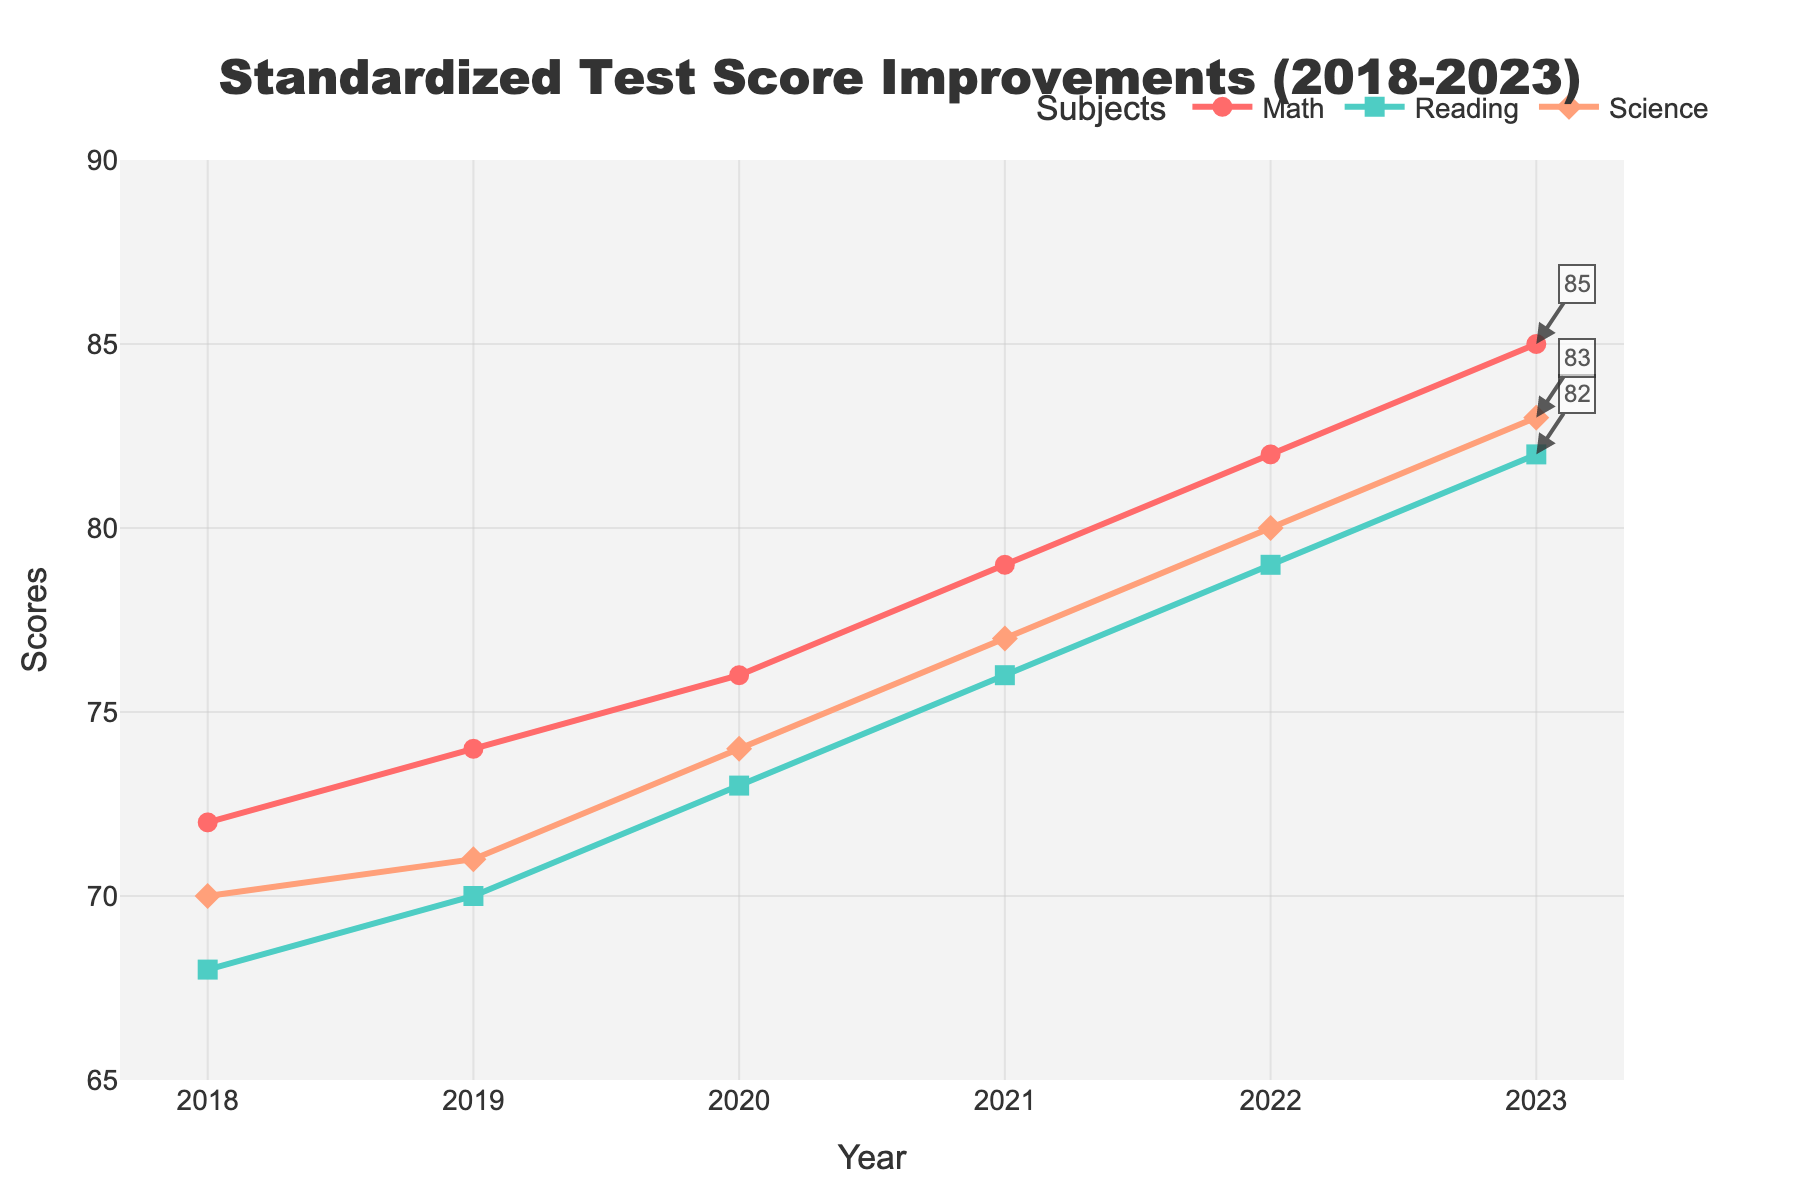What is the overall trend in Math scores from 2018 to 2023? The Math scores show a consistent upward trend from 72 in 2018 to 85 in 2023. By examining the line for Math scores, we see it steadily increases without any decline.
Answer: Increasing Which subject had the highest score in 2023? In 2023, all three subjects' scores are annotated on the graph. The Math score is 85, Reading score is 82, and Science score is 83. The highest score among these is the Math score.
Answer: Math Was there any year where the Reading scores exceeded the Science scores? By examining the lines for Reading and Science scores, we can see that the Reading scores were consistently below Science scores from 2018 to 2023.
Answer: No How much did the average score of all subjects increase from 2018 to 2023? First, calculate the average score for each year: 
2018: (72+68+70)/3 = 70 
2023: (85+82+83)/3 = 83.3 
Then, subtract the average score of 2018 from that of 2023: 83.3 - 70 = 13.3
Answer: 13.3 Did any subject show a constant yearly improvement without any dips from 2018 to 2023? By looking at the line for each subject, we see that all subjects show a steady upward trend without any dips or decreases in scores each year.
Answer: Yes, all subjects Which subject had the most improvement in scores from 2018 to 2023, and what is the value of this improvement? For Math: 85 - 72 = 13 
For Reading: 82 - 68 = 14 
For Science: 83 - 70 = 13 
Therefore, the Reading scores improved the most by 14 points.
Answer: Reading, 14 In what year did the Math scores first reach 80? By examining the Math scores plotted on the chart, we see that Math scores reached 80 and higher in 2022.
Answer: 2022 Compare the difference between Reading and Science scores in 2023 and determine which one is higher. In 2023, the Reading score is 82 and the Science score is 83. The difference is 83 - 82 = 1, with Science scores being higher.
Answer: Science, by 1 What is the total score of all three subjects in 2021? Sum the scores for 2021: Math: 79, Reading: 76, Science: 77. 79 + 76 + 77 = 232
Answer: 232 